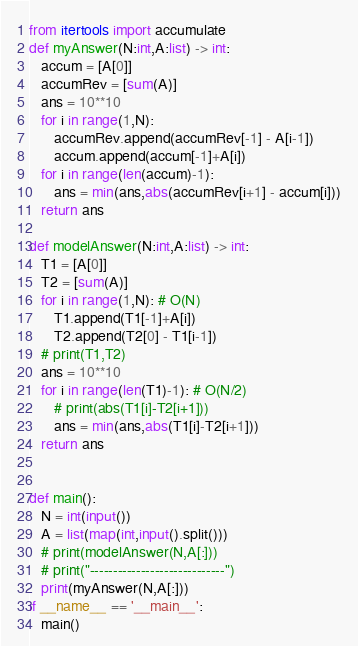Convert code to text. <code><loc_0><loc_0><loc_500><loc_500><_Python_>from itertools import accumulate
def myAnswer(N:int,A:list) -> int:
   accum = [A[0]]
   accumRev = [sum(A)]
   ans = 10**10
   for i in range(1,N):
      accumRev.append(accumRev[-1] - A[i-1])
      accum.append(accum[-1]+A[i])
   for i in range(len(accum)-1):
      ans = min(ans,abs(accumRev[i+1] - accum[i]))
   return ans
      
def modelAnswer(N:int,A:list) -> int:
   T1 = [A[0]]
   T2 = [sum(A)]
   for i in range(1,N): # O(N)
      T1.append(T1[-1]+A[i])
      T2.append(T2[0] - T1[i-1])
   # print(T1,T2)
   ans = 10**10
   for i in range(len(T1)-1): # O(N/2)
      # print(abs(T1[i]-T2[i+1]))
      ans = min(ans,abs(T1[i]-T2[i+1]))
   return ans


def main():
   N = int(input())
   A = list(map(int,input().split()))
   # print(modelAnswer(N,A[:]))
   # print("-----------------------------")
   print(myAnswer(N,A[:]))
if __name__ == '__main__':
   main()
</code> 